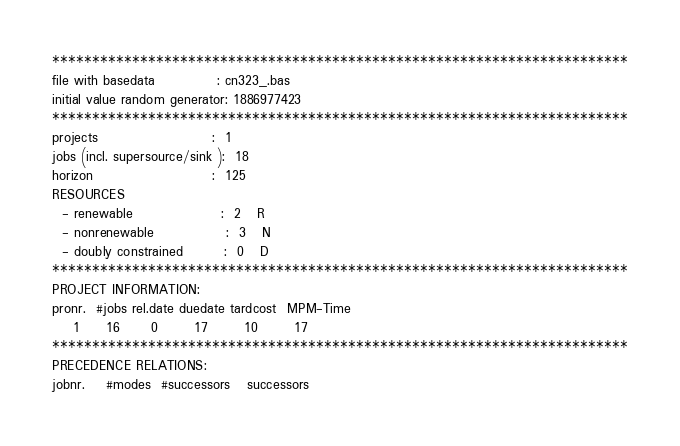Convert code to text. <code><loc_0><loc_0><loc_500><loc_500><_ObjectiveC_>************************************************************************
file with basedata            : cn323_.bas
initial value random generator: 1886977423
************************************************************************
projects                      :  1
jobs (incl. supersource/sink ):  18
horizon                       :  125
RESOURCES
  - renewable                 :  2   R
  - nonrenewable              :  3   N
  - doubly constrained        :  0   D
************************************************************************
PROJECT INFORMATION:
pronr.  #jobs rel.date duedate tardcost  MPM-Time
    1     16      0       17       10       17
************************************************************************
PRECEDENCE RELATIONS:
jobnr.    #modes  #successors   successors</code> 